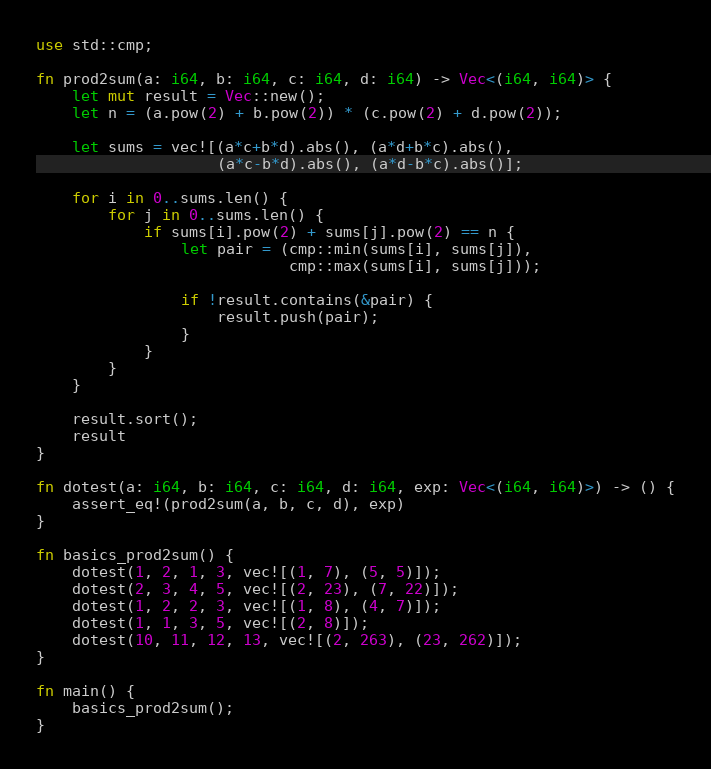<code> <loc_0><loc_0><loc_500><loc_500><_Rust_>use std::cmp;

fn prod2sum(a: i64, b: i64, c: i64, d: i64) -> Vec<(i64, i64)> {
    let mut result = Vec::new();
    let n = (a.pow(2) + b.pow(2)) * (c.pow(2) + d.pow(2));

    let sums = vec![(a*c+b*d).abs(), (a*d+b*c).abs(),
                    (a*c-b*d).abs(), (a*d-b*c).abs()];

    for i in 0..sums.len() {
        for j in 0..sums.len() {
            if sums[i].pow(2) + sums[j].pow(2) == n {
                let pair = (cmp::min(sums[i], sums[j]),
                            cmp::max(sums[i], sums[j]));

                if !result.contains(&pair) {
                    result.push(pair);
                }
            }
        }
    }

    result.sort();
    result
}

fn dotest(a: i64, b: i64, c: i64, d: i64, exp: Vec<(i64, i64)>) -> () {
    assert_eq!(prod2sum(a, b, c, d), exp)
}

fn basics_prod2sum() {
    dotest(1, 2, 1, 3, vec![(1, 7), (5, 5)]);
    dotest(2, 3, 4, 5, vec![(2, 23), (7, 22)]);
    dotest(1, 2, 2, 3, vec![(1, 8), (4, 7)]);
    dotest(1, 1, 3, 5, vec![(2, 8)]);
    dotest(10, 11, 12, 13, vec![(2, 263), (23, 262)]);
}

fn main() {
    basics_prod2sum();
}
</code> 